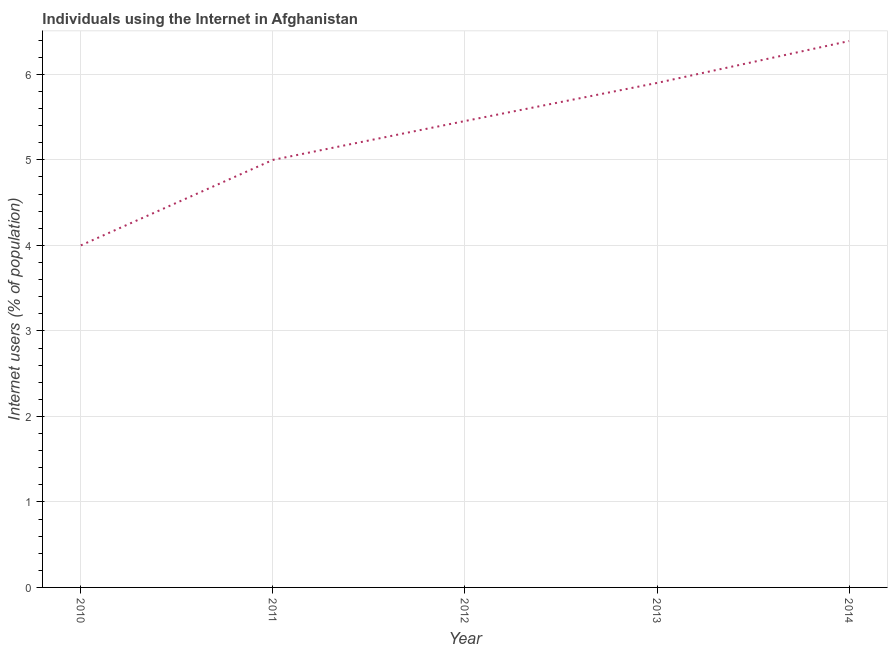Across all years, what is the maximum number of internet users?
Your answer should be compact. 6.39. In which year was the number of internet users maximum?
Give a very brief answer. 2014. What is the sum of the number of internet users?
Your answer should be very brief. 26.74. What is the difference between the number of internet users in 2012 and 2014?
Make the answer very short. -0.94. What is the average number of internet users per year?
Make the answer very short. 5.35. What is the median number of internet users?
Give a very brief answer. 5.45. What is the ratio of the number of internet users in 2010 to that in 2012?
Ensure brevity in your answer.  0.73. What is the difference between the highest and the second highest number of internet users?
Give a very brief answer. 0.49. Is the sum of the number of internet users in 2012 and 2013 greater than the maximum number of internet users across all years?
Your answer should be very brief. Yes. What is the difference between the highest and the lowest number of internet users?
Your answer should be compact. 2.39. How many lines are there?
Your response must be concise. 1. Are the values on the major ticks of Y-axis written in scientific E-notation?
Your answer should be compact. No. Does the graph contain any zero values?
Keep it short and to the point. No. Does the graph contain grids?
Offer a very short reply. Yes. What is the title of the graph?
Offer a very short reply. Individuals using the Internet in Afghanistan. What is the label or title of the X-axis?
Provide a short and direct response. Year. What is the label or title of the Y-axis?
Give a very brief answer. Internet users (% of population). What is the Internet users (% of population) in 2010?
Make the answer very short. 4. What is the Internet users (% of population) in 2011?
Make the answer very short. 5. What is the Internet users (% of population) in 2012?
Your answer should be compact. 5.45. What is the Internet users (% of population) in 2013?
Provide a short and direct response. 5.9. What is the Internet users (% of population) of 2014?
Offer a terse response. 6.39. What is the difference between the Internet users (% of population) in 2010 and 2012?
Make the answer very short. -1.45. What is the difference between the Internet users (% of population) in 2010 and 2013?
Your response must be concise. -1.9. What is the difference between the Internet users (% of population) in 2010 and 2014?
Your answer should be very brief. -2.39. What is the difference between the Internet users (% of population) in 2011 and 2012?
Provide a short and direct response. -0.45. What is the difference between the Internet users (% of population) in 2011 and 2014?
Provide a short and direct response. -1.39. What is the difference between the Internet users (% of population) in 2012 and 2013?
Your response must be concise. -0.45. What is the difference between the Internet users (% of population) in 2012 and 2014?
Offer a terse response. -0.94. What is the difference between the Internet users (% of population) in 2013 and 2014?
Ensure brevity in your answer.  -0.49. What is the ratio of the Internet users (% of population) in 2010 to that in 2012?
Your answer should be compact. 0.73. What is the ratio of the Internet users (% of population) in 2010 to that in 2013?
Ensure brevity in your answer.  0.68. What is the ratio of the Internet users (% of population) in 2010 to that in 2014?
Your response must be concise. 0.63. What is the ratio of the Internet users (% of population) in 2011 to that in 2012?
Your answer should be compact. 0.92. What is the ratio of the Internet users (% of population) in 2011 to that in 2013?
Your response must be concise. 0.85. What is the ratio of the Internet users (% of population) in 2011 to that in 2014?
Offer a terse response. 0.78. What is the ratio of the Internet users (% of population) in 2012 to that in 2013?
Offer a terse response. 0.92. What is the ratio of the Internet users (% of population) in 2012 to that in 2014?
Your response must be concise. 0.85. What is the ratio of the Internet users (% of population) in 2013 to that in 2014?
Provide a succinct answer. 0.92. 